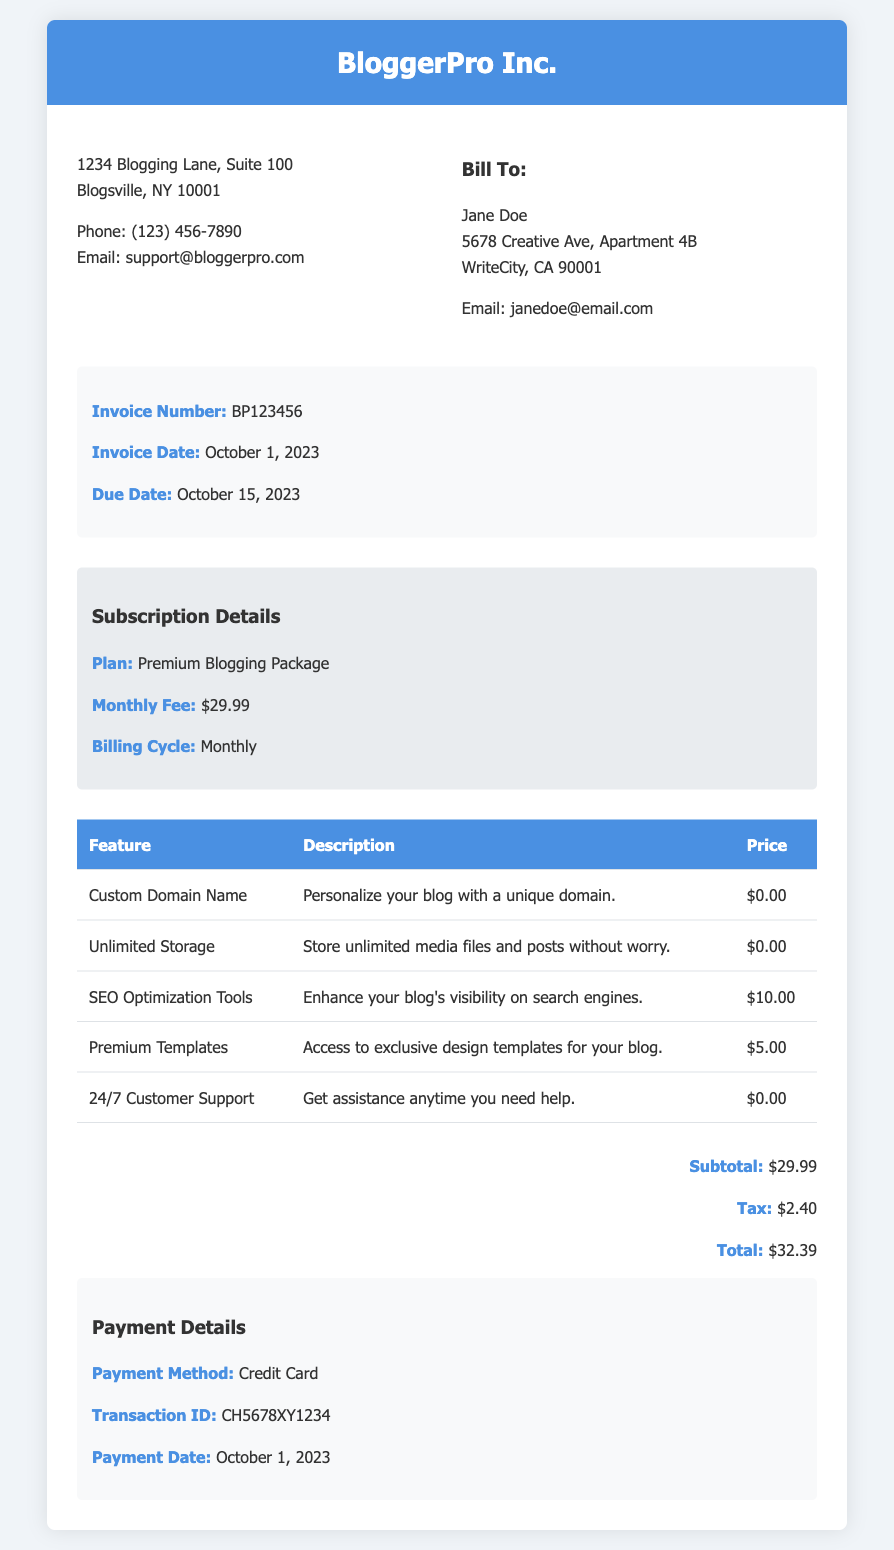What is the invoice number? The invoice number is displayed clearly in the document under invoice details.
Answer: BP123456 What is the total amount due? The total amount is found in the totals section of the document.
Answer: $32.39 What is the invoice date? The invoice date is provided in the invoice details section.
Answer: October 1, 2023 What plan is subscribed to? The subscription plan is clearly stated in the subscription details section.
Answer: Premium Blogging Package What is the payment method? The payment method is listed in the payment information section of the document.
Answer: Credit Card How many features are itemized in the document? The number of features can be counted from the features table in the document.
Answer: 5 What is the tax amount? The tax amount can be found in the totals section.
Answer: $2.40 What feature has an associated cost of $10.00? The feature with this cost is specified in the features table.
Answer: SEO Optimization Tools What is the due date for the invoice? The due date is mentioned in the invoice details section.
Answer: October 15, 2023 